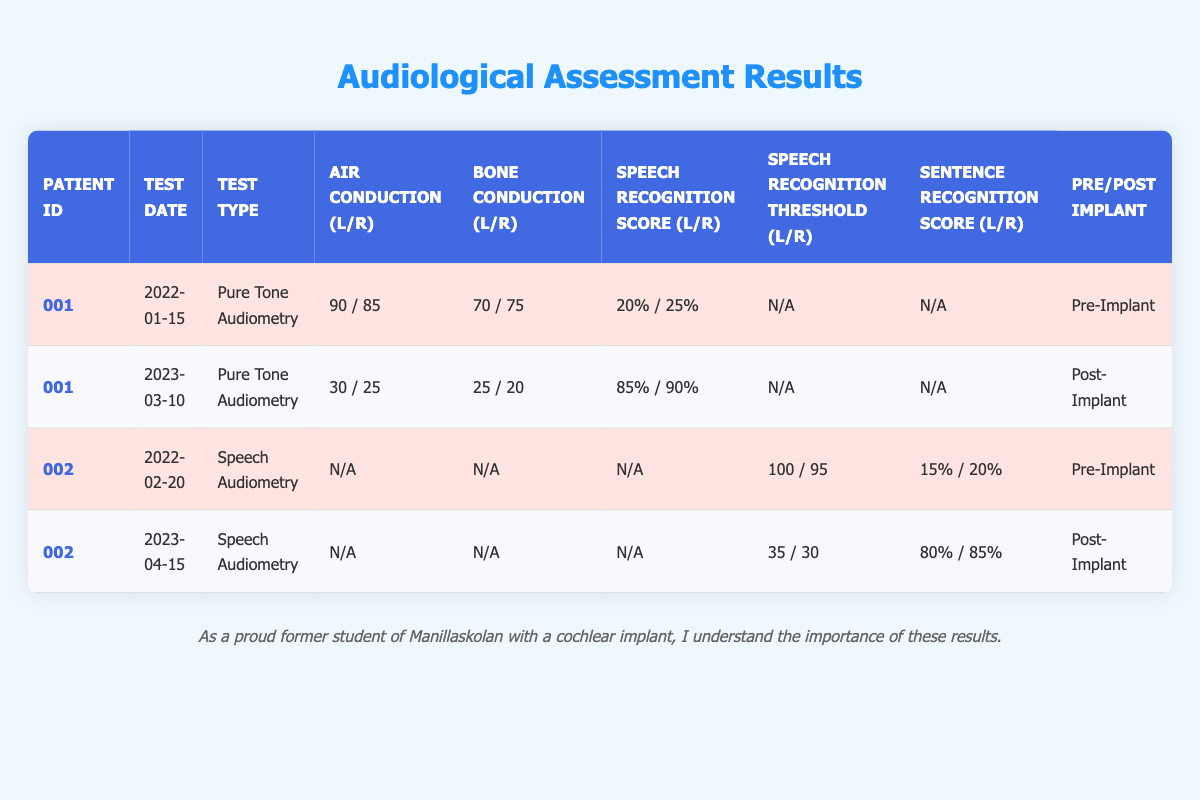What were the air conduction results for the right ear before the cochlear implantation for patient 001? The air conduction result for the right ear before cochlear implantation for patient 001 is found in the first row of the table under the "Air Conduction" column. It shows 85.
Answer: 85 What is the sentence recognition score for the left ear after cochlear implantation for patient 002? The sentence recognition score for the left ear after cochlear implantation for patient 002 is found in the last row, under the "Sentence Recognition Score" column. It shows 80%.
Answer: 80% What is the average speech recognition score for both ears before the cochlear implantation for patient 001? The speech recognition scores before implantation for patient 001 are 20% for the left ear and 25% for the right ear. Adding these gives 20 + 25 = 45, and dividing this by 2 gives an average of 22.5.
Answer: 22.5 Did patient 002 have a better speech recognition threshold in the left ear before or after implantation? The speech recognition threshold for the left ear before implantation is 100, while after implantation it is 35. Since 35 is lower than 100, it indicates that the threshold improved after implantation.
Answer: Yes What were the bone conduction results for the right ear after the cochlear implantation for patient 001? The bone conduction results for the right ear after cochlear implantation for patient 001 are found in the second row of the table under the "Bone Conduction" column. It shows 20.
Answer: 20 What is the difference in speech recognition threshold for the right ear before and after the cochlear implantation for patient 002? The speech recognition threshold for the right ear before implantation is 95, and after implantation it is 30. The difference is calculated as 95 - 30 = 65, meaning there was a significant improvement after implantation.
Answer: 65 What type of audiometric test was performed for patient 001 after the cochlear implantation? For patient 001, the type of audiometric test after cochlear implantation is listed in the second row of the table under the "Test Type" column, which is "Pure Tone Audiometry."
Answer: Pure Tone Audiometry Were the speech recognition scores better for the left ear before or after cochlear implantation for patient 001? The speech recognition score for the left ear before implantation is 20%, and after implantation it is 85%. Since 85% is greater than 20%, the scores improved after implantation.
Answer: Yes 